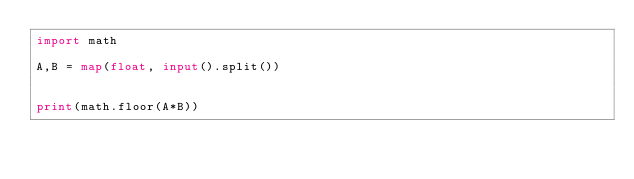Convert code to text. <code><loc_0><loc_0><loc_500><loc_500><_Python_>import math

A,B = map(float, input().split())


print(math.floor(A*B))</code> 